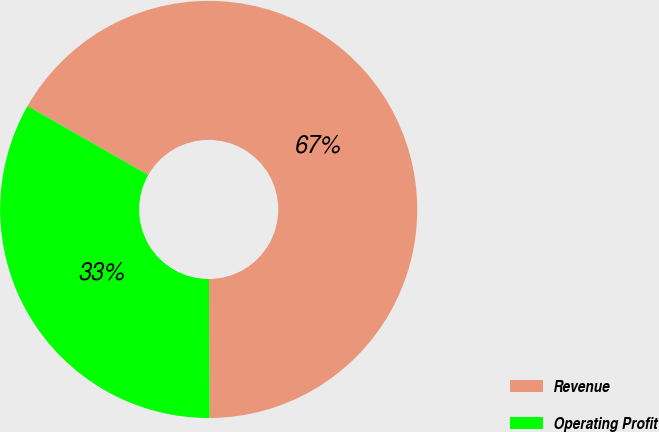Convert chart to OTSL. <chart><loc_0><loc_0><loc_500><loc_500><pie_chart><fcel>Revenue<fcel>Operating Profit<nl><fcel>66.67%<fcel>33.33%<nl></chart> 